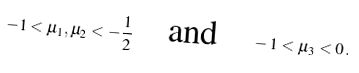Convert formula to latex. <formula><loc_0><loc_0><loc_500><loc_500>- 1 < \mu _ { 1 } , \mu _ { 2 } < - \frac { 1 } { 2 } \quad \text {and} \quad - 1 < \mu _ { 3 } < 0 \, .</formula> 